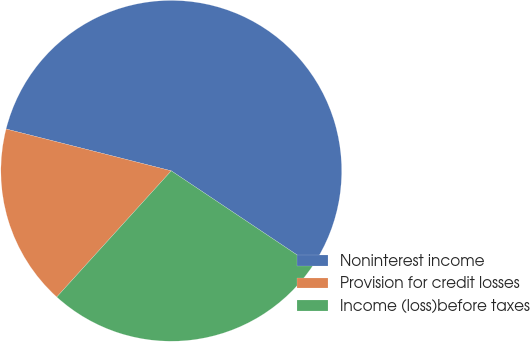Convert chart. <chart><loc_0><loc_0><loc_500><loc_500><pie_chart><fcel>Noninterest income<fcel>Provision for credit losses<fcel>Income (loss)before taxes<nl><fcel>55.43%<fcel>17.22%<fcel>27.35%<nl></chart> 